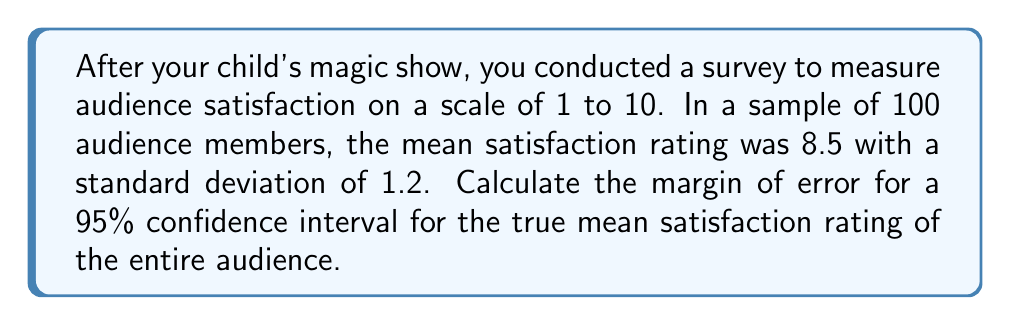Show me your answer to this math problem. To calculate the margin of error for a 95% confidence interval, we'll follow these steps:

1. Identify the given information:
   - Sample size (n) = 100
   - Sample mean (x̄) = 8.5
   - Sample standard deviation (s) = 1.2
   - Confidence level = 95%

2. Determine the critical value (z*) for a 95% confidence interval:
   The z* value for a 95% confidence interval is 1.96.

3. Calculate the standard error (SE) of the mean:
   $$ SE = \frac{s}{\sqrt{n}} = \frac{1.2}{\sqrt{100}} = \frac{1.2}{10} = 0.12 $$

4. Calculate the margin of error (ME):
   $$ ME = z* \times SE = 1.96 \times 0.12 = 0.2352 $$

5. Round the margin of error to three decimal places:
   ME ≈ 0.235

The margin of error represents the range above and below the sample mean within which we can be 95% confident that the true population mean falls.
Answer: 0.235 